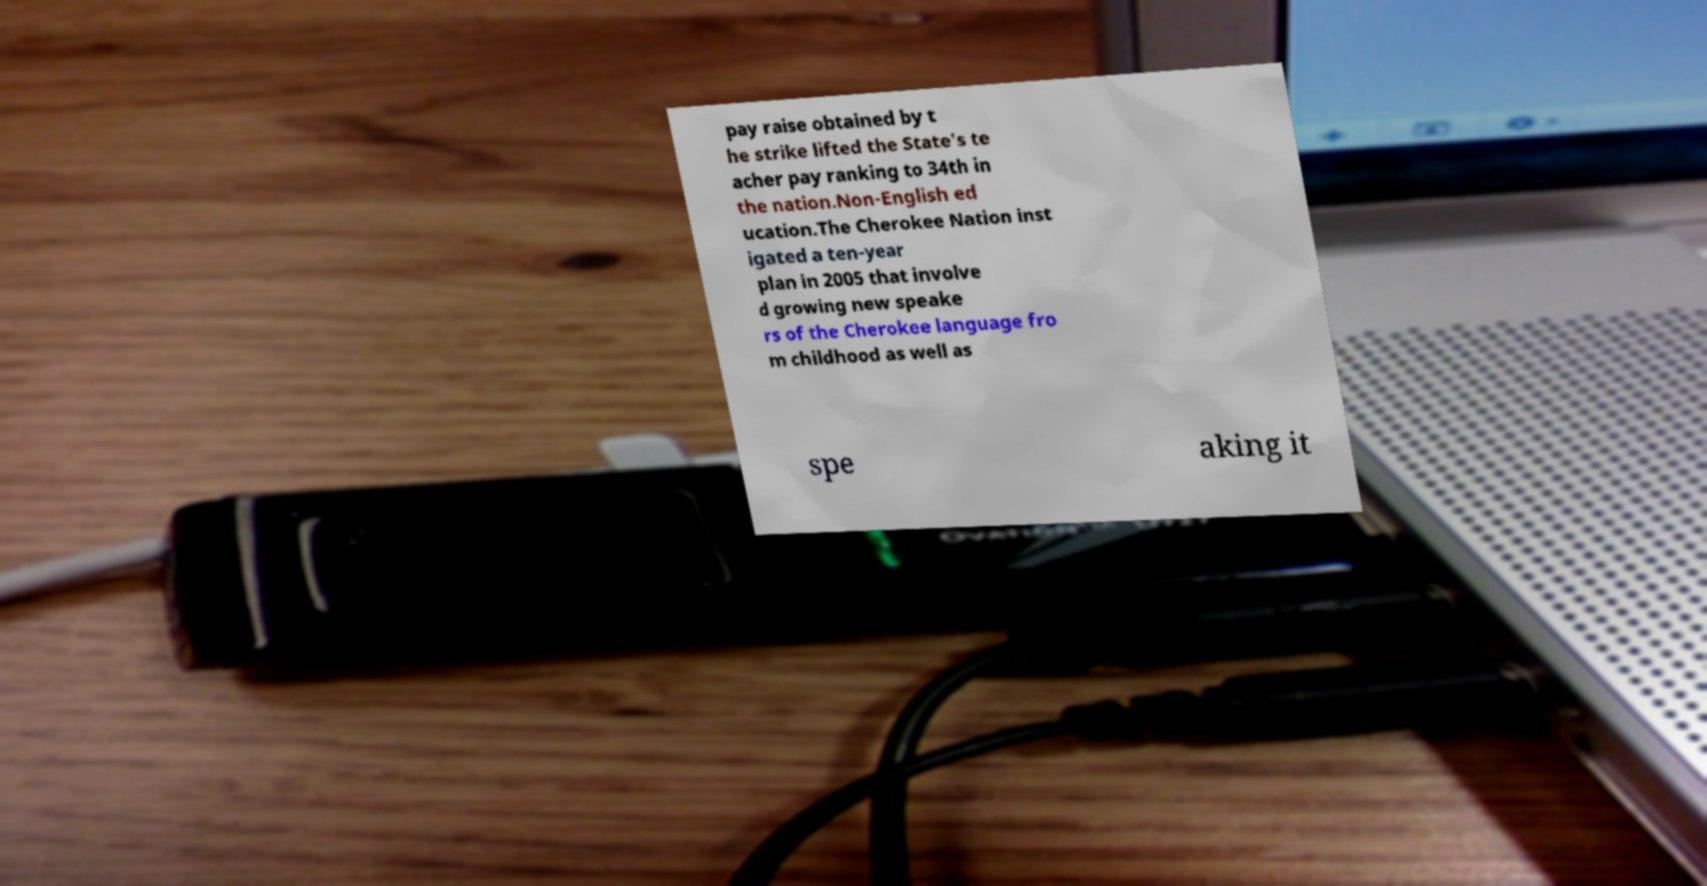Could you extract and type out the text from this image? pay raise obtained by t he strike lifted the State's te acher pay ranking to 34th in the nation.Non-English ed ucation.The Cherokee Nation inst igated a ten-year plan in 2005 that involve d growing new speake rs of the Cherokee language fro m childhood as well as spe aking it 